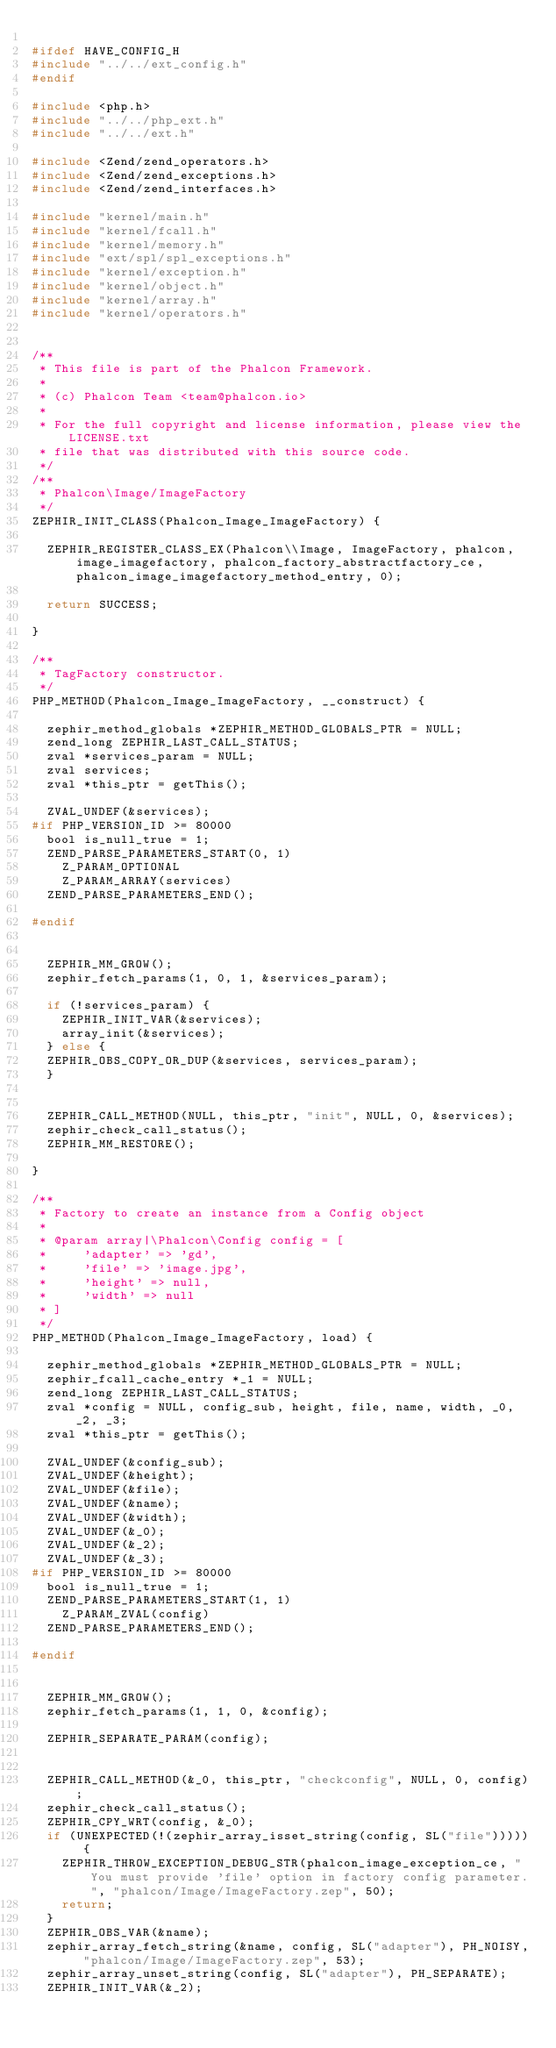Convert code to text. <code><loc_0><loc_0><loc_500><loc_500><_C_>
#ifdef HAVE_CONFIG_H
#include "../../ext_config.h"
#endif

#include <php.h>
#include "../../php_ext.h"
#include "../../ext.h"

#include <Zend/zend_operators.h>
#include <Zend/zend_exceptions.h>
#include <Zend/zend_interfaces.h>

#include "kernel/main.h"
#include "kernel/fcall.h"
#include "kernel/memory.h"
#include "ext/spl/spl_exceptions.h"
#include "kernel/exception.h"
#include "kernel/object.h"
#include "kernel/array.h"
#include "kernel/operators.h"


/**
 * This file is part of the Phalcon Framework.
 *
 * (c) Phalcon Team <team@phalcon.io>
 *
 * For the full copyright and license information, please view the LICENSE.txt
 * file that was distributed with this source code.
 */
/**
 * Phalcon\Image/ImageFactory
 */
ZEPHIR_INIT_CLASS(Phalcon_Image_ImageFactory) {

	ZEPHIR_REGISTER_CLASS_EX(Phalcon\\Image, ImageFactory, phalcon, image_imagefactory, phalcon_factory_abstractfactory_ce, phalcon_image_imagefactory_method_entry, 0);

	return SUCCESS;

}

/**
 * TagFactory constructor.
 */
PHP_METHOD(Phalcon_Image_ImageFactory, __construct) {

	zephir_method_globals *ZEPHIR_METHOD_GLOBALS_PTR = NULL;
	zend_long ZEPHIR_LAST_CALL_STATUS;
	zval *services_param = NULL;
	zval services;
	zval *this_ptr = getThis();

	ZVAL_UNDEF(&services);
#if PHP_VERSION_ID >= 80000
	bool is_null_true = 1;
	ZEND_PARSE_PARAMETERS_START(0, 1)
		Z_PARAM_OPTIONAL
		Z_PARAM_ARRAY(services)
	ZEND_PARSE_PARAMETERS_END();

#endif


	ZEPHIR_MM_GROW();
	zephir_fetch_params(1, 0, 1, &services_param);

	if (!services_param) {
		ZEPHIR_INIT_VAR(&services);
		array_init(&services);
	} else {
	ZEPHIR_OBS_COPY_OR_DUP(&services, services_param);
	}


	ZEPHIR_CALL_METHOD(NULL, this_ptr, "init", NULL, 0, &services);
	zephir_check_call_status();
	ZEPHIR_MM_RESTORE();

}

/**
 * Factory to create an instance from a Config object
 *
 * @param array|\Phalcon\Config config = [
 *     'adapter' => 'gd',
 *     'file' => 'image.jpg',
 *     'height' => null,
 *     'width' => null
 * ]
 */
PHP_METHOD(Phalcon_Image_ImageFactory, load) {

	zephir_method_globals *ZEPHIR_METHOD_GLOBALS_PTR = NULL;
	zephir_fcall_cache_entry *_1 = NULL;
	zend_long ZEPHIR_LAST_CALL_STATUS;
	zval *config = NULL, config_sub, height, file, name, width, _0, _2, _3;
	zval *this_ptr = getThis();

	ZVAL_UNDEF(&config_sub);
	ZVAL_UNDEF(&height);
	ZVAL_UNDEF(&file);
	ZVAL_UNDEF(&name);
	ZVAL_UNDEF(&width);
	ZVAL_UNDEF(&_0);
	ZVAL_UNDEF(&_2);
	ZVAL_UNDEF(&_3);
#if PHP_VERSION_ID >= 80000
	bool is_null_true = 1;
	ZEND_PARSE_PARAMETERS_START(1, 1)
		Z_PARAM_ZVAL(config)
	ZEND_PARSE_PARAMETERS_END();

#endif


	ZEPHIR_MM_GROW();
	zephir_fetch_params(1, 1, 0, &config);

	ZEPHIR_SEPARATE_PARAM(config);


	ZEPHIR_CALL_METHOD(&_0, this_ptr, "checkconfig", NULL, 0, config);
	zephir_check_call_status();
	ZEPHIR_CPY_WRT(config, &_0);
	if (UNEXPECTED(!(zephir_array_isset_string(config, SL("file"))))) {
		ZEPHIR_THROW_EXCEPTION_DEBUG_STR(phalcon_image_exception_ce, "You must provide 'file' option in factory config parameter.", "phalcon/Image/ImageFactory.zep", 50);
		return;
	}
	ZEPHIR_OBS_VAR(&name);
	zephir_array_fetch_string(&name, config, SL("adapter"), PH_NOISY, "phalcon/Image/ImageFactory.zep", 53);
	zephir_array_unset_string(config, SL("adapter"), PH_SEPARATE);
	ZEPHIR_INIT_VAR(&_2);</code> 